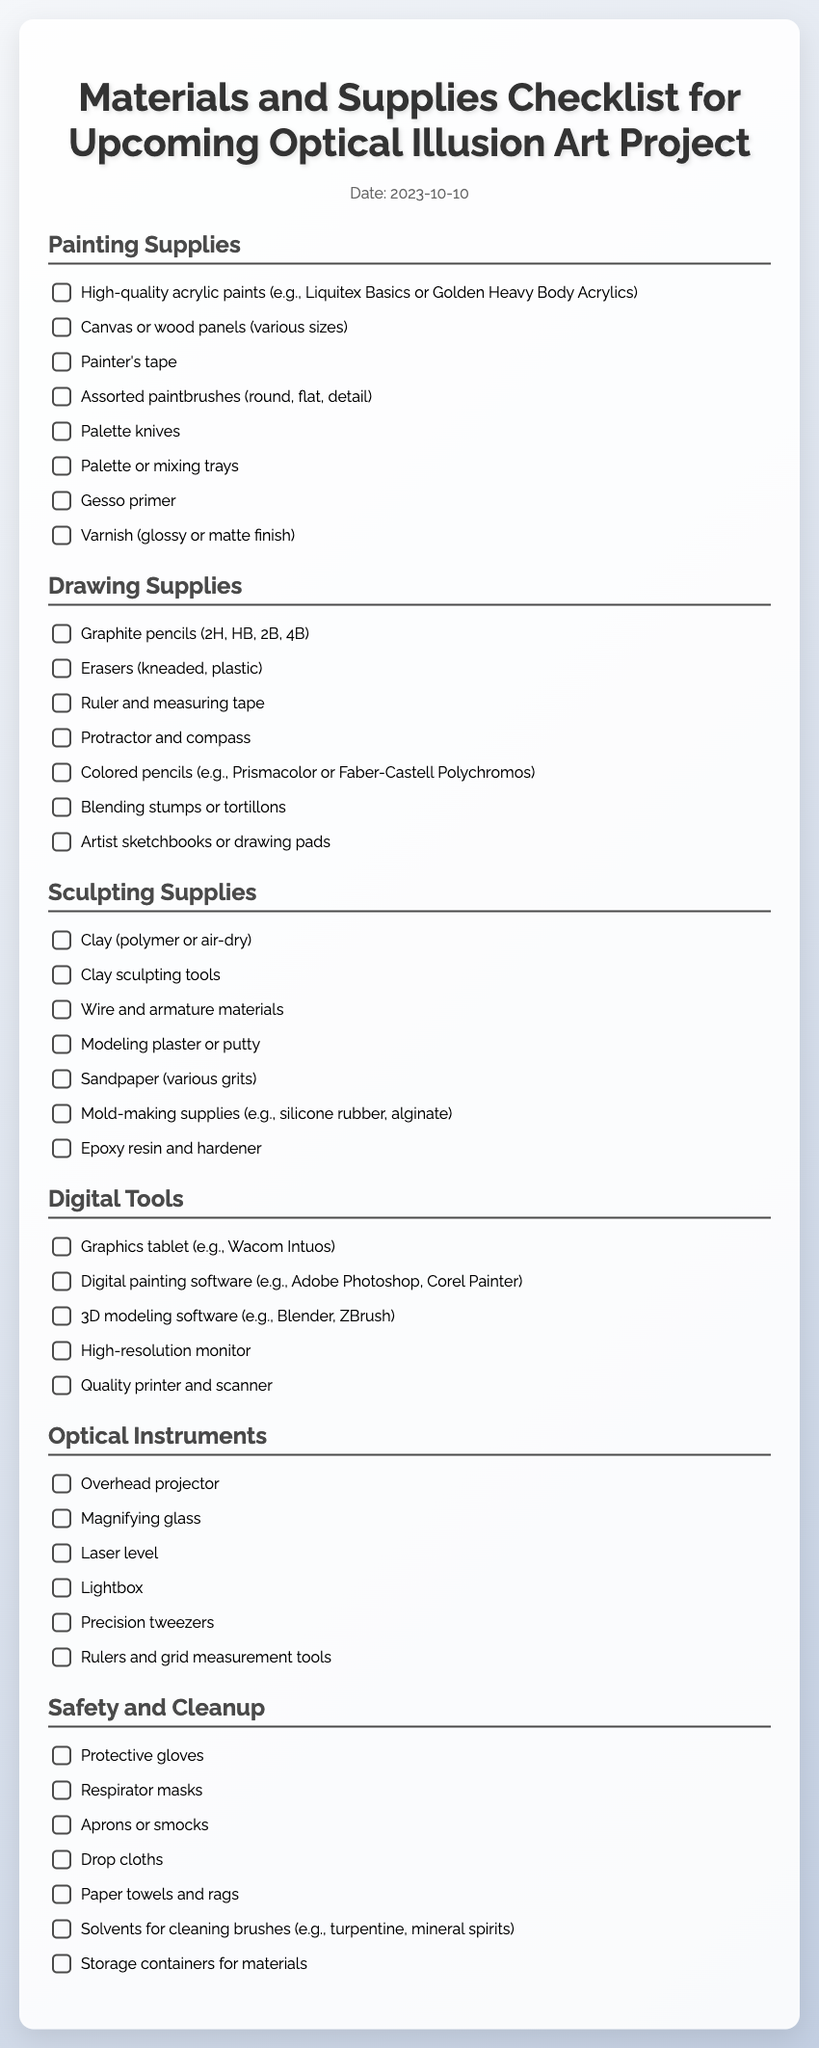what date is the checklist for? The date mentioned in the checklist is provided in the document header.
Answer: 2023-10-10 how many categories of supplies are listed? The document contains several distinct categories for different types of supplies.
Answer: 6 what is the first item listed under Painting Supplies? The first item listed under the Painting Supplies category gives information about the type of paints needed.
Answer: High-quality acrylic paints which tool is mentioned for measuring? A specific tool is listed in the drawing supplies that is used for measuring lengths and angles.
Answer: Ruler and measuring tape how many digital tools are included in the checklist? The count of items in the Digital Tools category is provided in the list.
Answer: 5 what type of clay is recommended for sculpting? The type of clay mentioned for sculpting in the checklist includes various options suitable for artists.
Answer: Polymer or air-dry which item is listed under Optical Instruments for precision work? The checklist includes an item that assists with detailed work and adjustments in art.
Answer: Precision tweezers how many items are in the Safety and Cleanup section? The document states a specific number of items dedicated to safety and cleanup protocols.
Answer: 7 what is the last item listed in Drawing Supplies? The last item listed in the Drawing Supplies category refers to the materials used for sketching and drawing.
Answer: Artist sketchbooks or drawing pads 